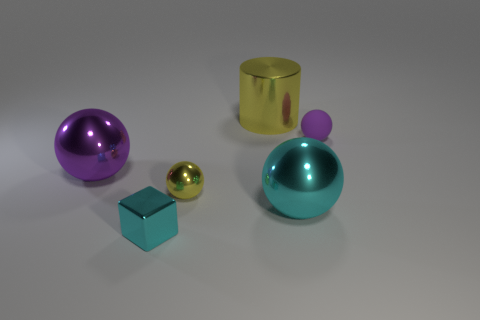What can you infer about the surface on which the objects are placed? The surface appears to be a matte, slightly reflective material, possible a type of smooth concrete or stone. It's uniformly colored with no distinct texture, which allows the reflections of the objects to show subtly, giving a sense of the surface's smoothness and the overall minimalist nature of the scene. 